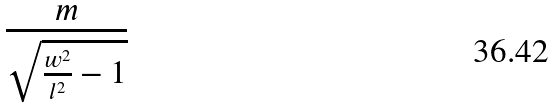<formula> <loc_0><loc_0><loc_500><loc_500>\frac { m } { \sqrt { \frac { w ^ { 2 } } { l ^ { 2 } } - 1 } }</formula> 